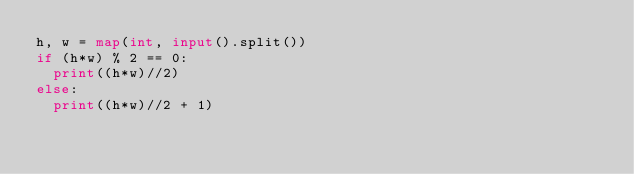Convert code to text. <code><loc_0><loc_0><loc_500><loc_500><_Python_>h, w = map(int, input().split())
if (h*w) % 2 == 0:
  print((h*w)//2)
else:
  print((h*w)//2 + 1)</code> 